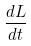<formula> <loc_0><loc_0><loc_500><loc_500>\frac { d L } { d t }</formula> 